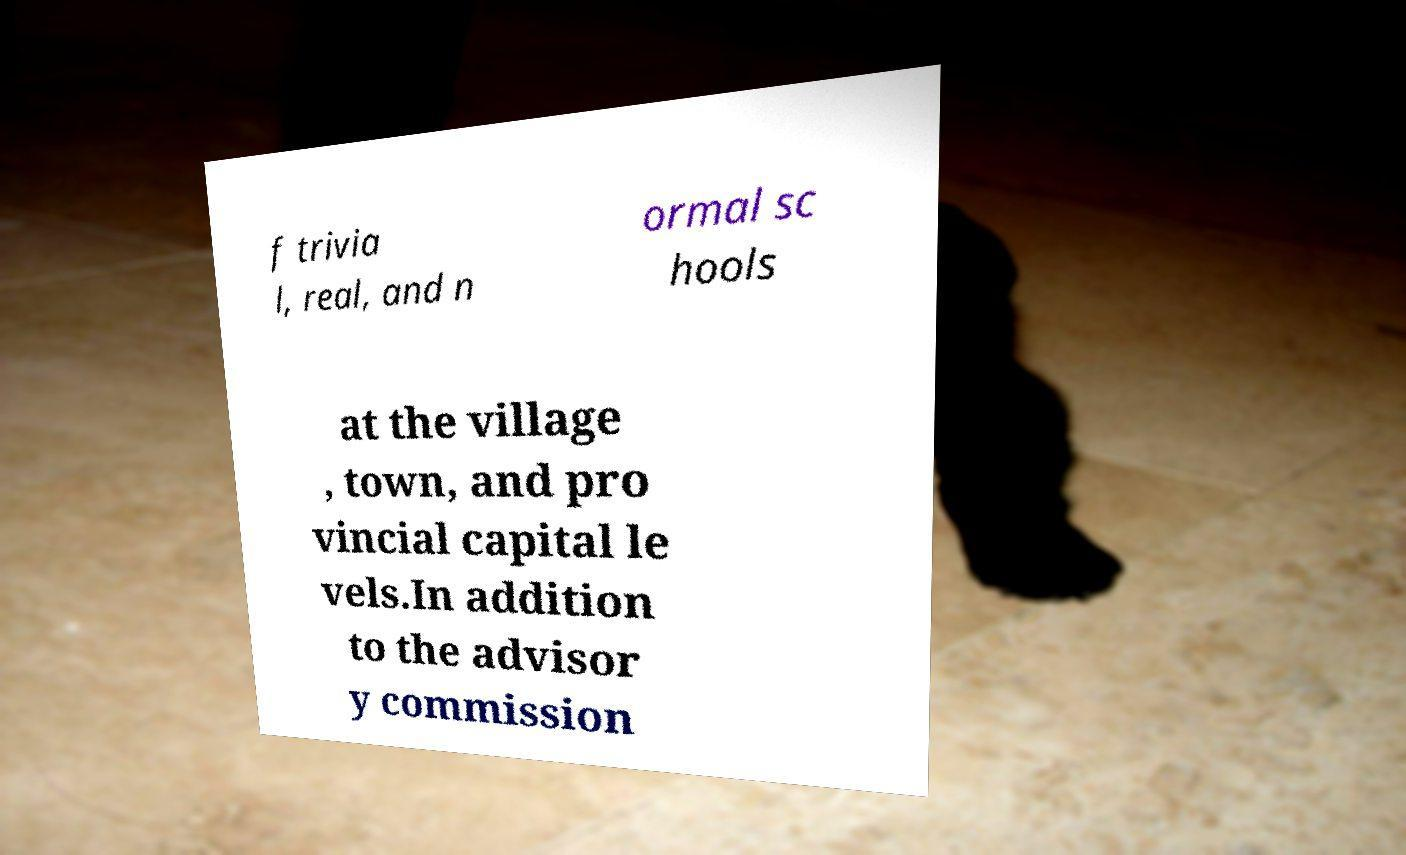What messages or text are displayed in this image? I need them in a readable, typed format. f trivia l, real, and n ormal sc hools at the village , town, and pro vincial capital le vels.In addition to the advisor y commission 